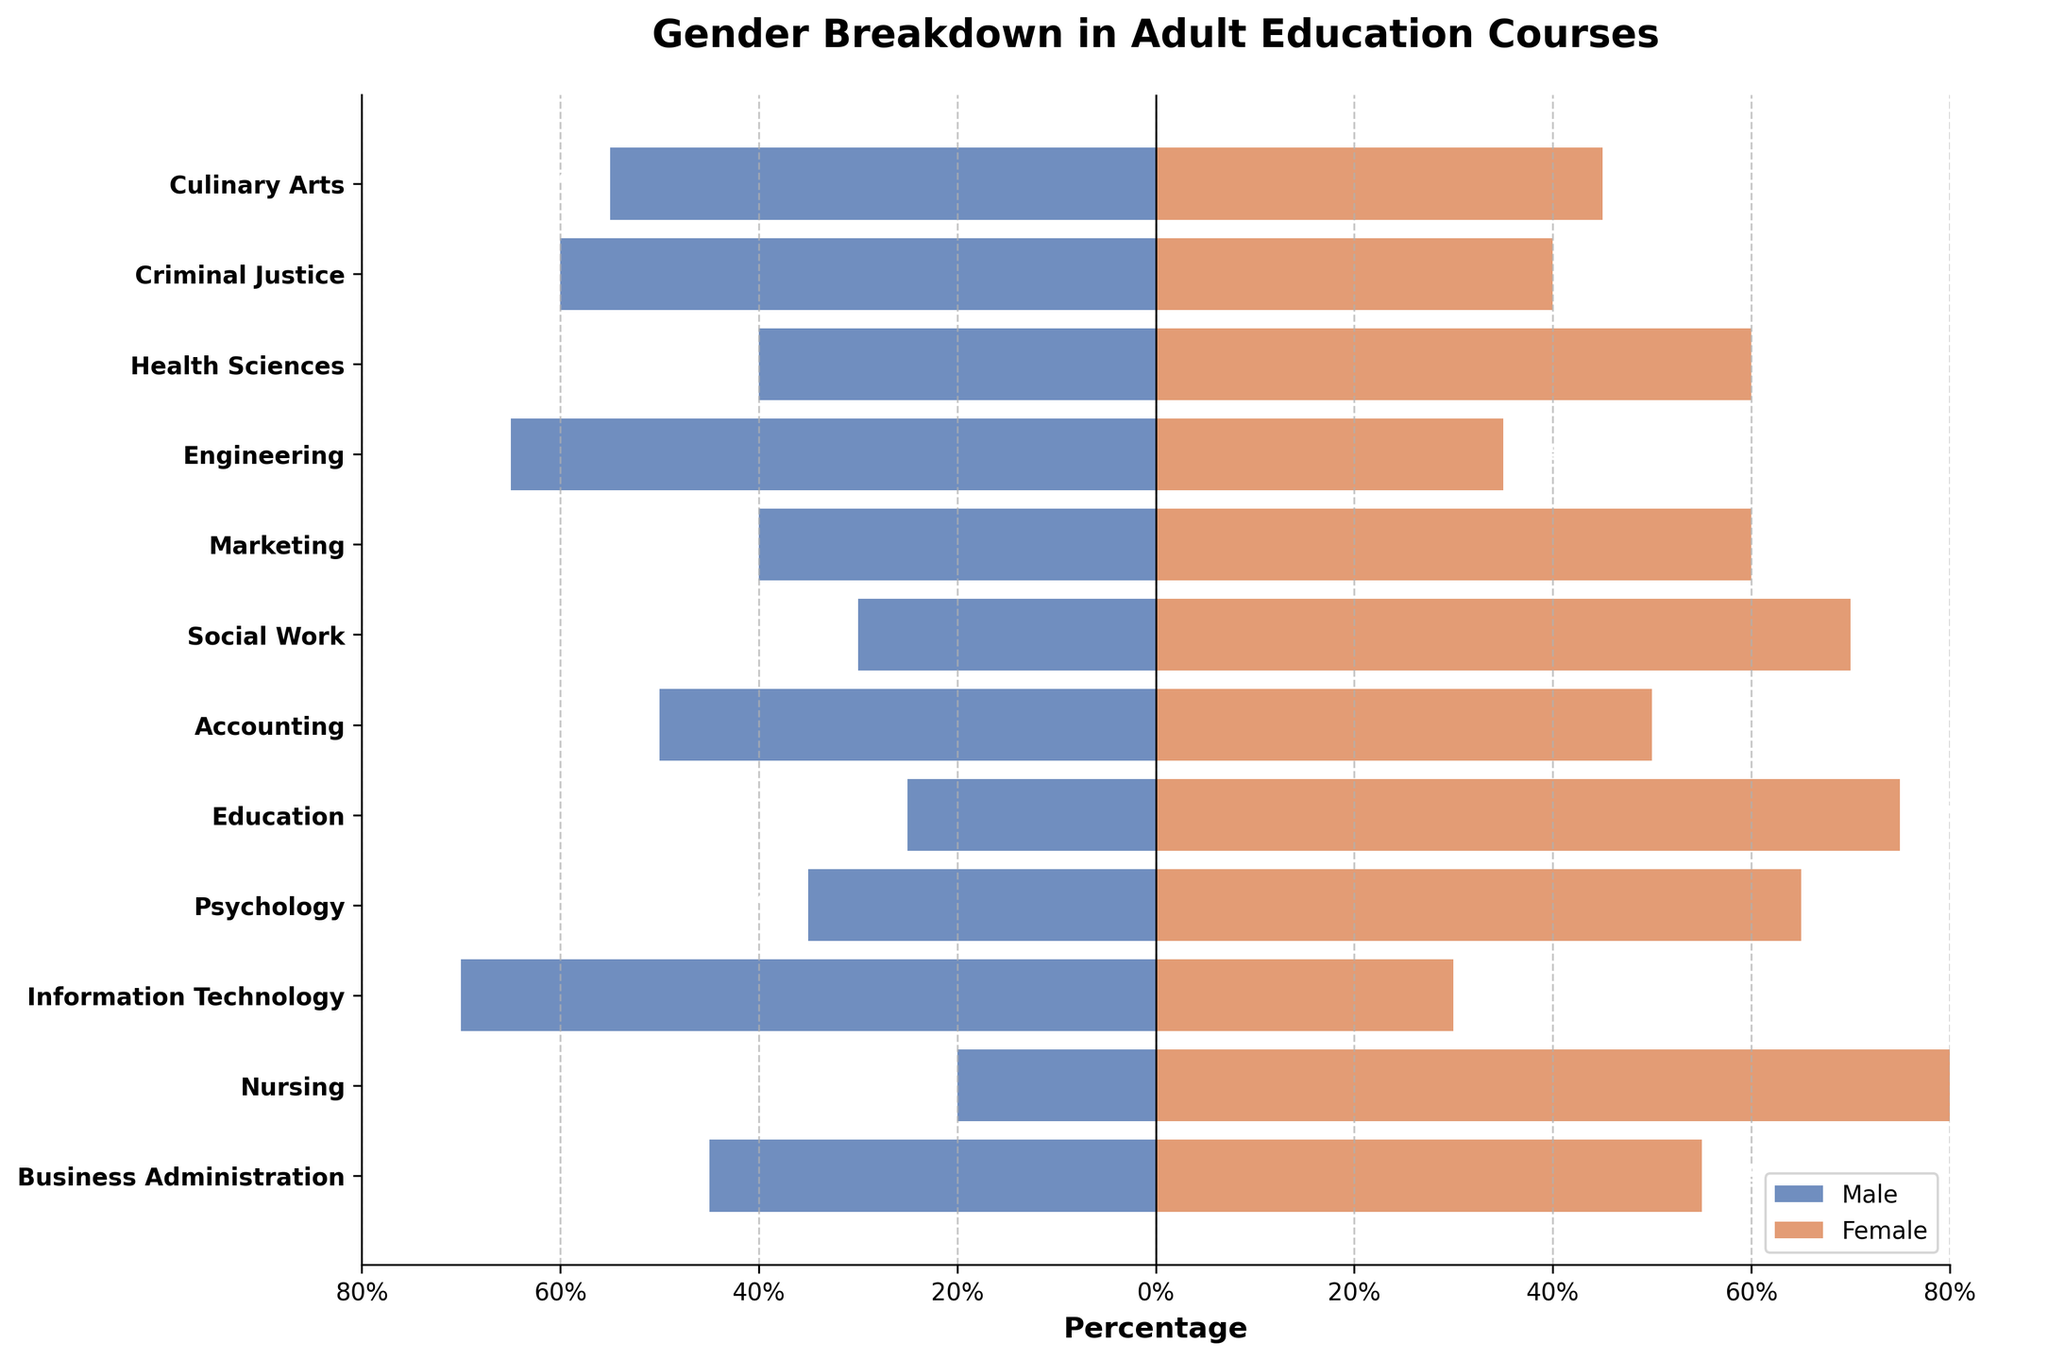Which course has the highest percentage of female students? From the figure, we observe that Nursing has the highest percentage of female students at 80%
Answer: Nursing Which course has the highest percentage of male students? From the figure, we identify that Information Technology has the highest percentage of male students at 70%
Answer: Information Technology What is the combined percentage of male and female students in Engineering? The figure indicates 65% male and 35% female in Engineering. Adding these together, we get 65% + 35% = 100%
Answer: 100% Which courses have an equal distribution of male and female students? The figure shows that Accounting has 50% male and 50% female students
Answer: Accounting How does the gender distribution in Business Administration compare to Education? Business Administration has 45% male and 55% female, while Education has 25% male and 75% female. Business Administration has a more balanced gender ratio compared to Education
Answer: Business Administration has a more balanced gender ratio What is the difference in the percentage of male students between Criminal Justice and Marketing? The figure shows 60% male in Criminal Justice and 40% male in Marketing. The difference is 60% - 40% = 20%
Answer: 20% Which courses have more than 60% female students? The figure shows that Nursing, Psychology, Education, and Social Work have more than 60% female students
Answer: Nursing, Psychology, Education, Social Work What percentage of students in Culinary Arts are female? From the figure, we see that Culinary Arts has 45% female students
Answer: 45% Which course has a higher percentage of female students, Health Sciences or Marketing? The figure shows that Health Sciences has 60% female students and Marketing also has 60% female students. Both courses have the same percentage of female students
Answer: Both have the same percentage 